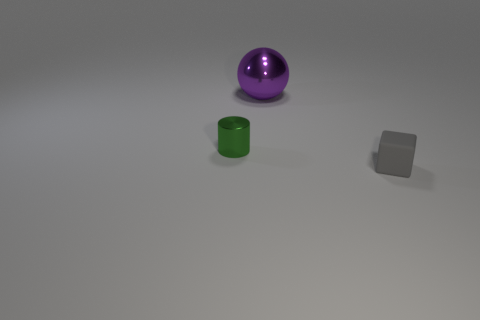Does the small green thing have the same material as the small block?
Offer a very short reply. No. Is the number of large objects less than the number of tiny green cubes?
Offer a very short reply. No. There is a object that is in front of the tiny metal cylinder; what is its color?
Your response must be concise. Gray. There is a object that is both in front of the metallic sphere and on the left side of the rubber block; what is it made of?
Keep it short and to the point. Metal. There is a tiny thing that is made of the same material as the purple ball; what shape is it?
Your answer should be very brief. Cylinder. There is a tiny object that is to the left of the rubber object; what number of objects are to the right of it?
Provide a succinct answer. 2. How many things are to the left of the small gray matte thing and in front of the purple sphere?
Provide a succinct answer. 1. What number of other things are the same material as the gray block?
Your answer should be compact. 0. There is a metal thing that is behind the small thing on the left side of the gray cube; what color is it?
Your answer should be very brief. Purple. There is a tiny object behind the gray object; does it have the same color as the large sphere?
Give a very brief answer. No. 